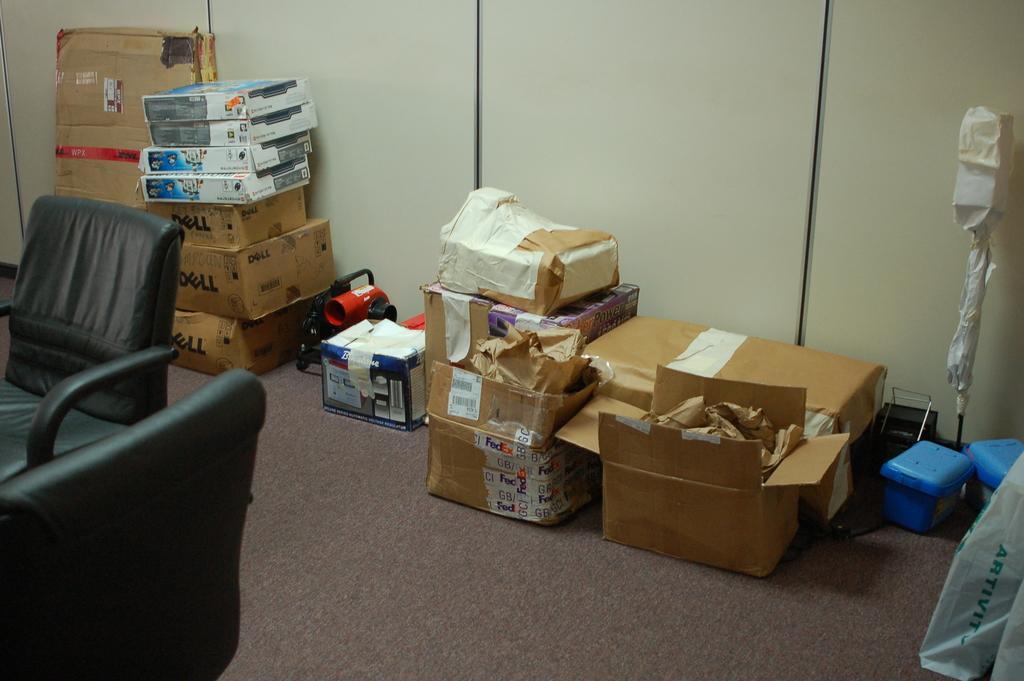Can you describe this image briefly? In this picture we can see a chair and couple of boxes. 